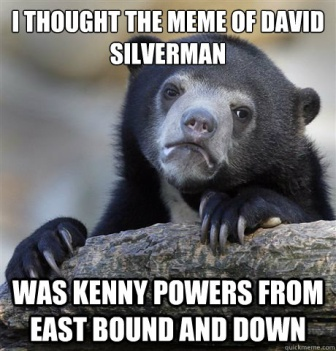What is the text overlay in the image trying to convey? The text overlay in the image suggests a humorous mix-up between two individuals, David Silverman and Kenny Powers, a character from the TV show 'East Bound and Down.' The bear's puzzled expression complements this mix-up, adding to the humor. 